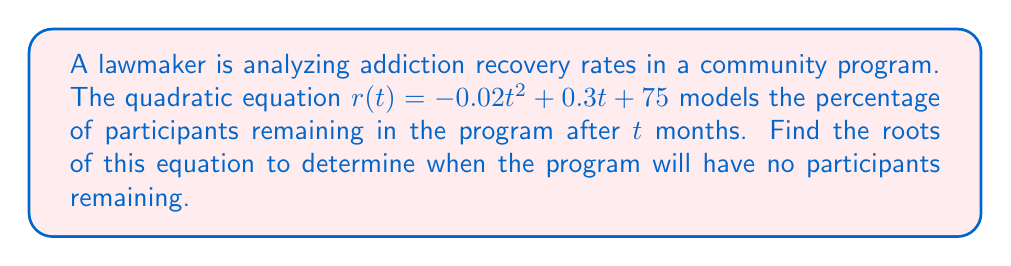Teach me how to tackle this problem. To find the roots of the quadratic equation, we need to solve $r(t) = 0$:

1) Set the equation equal to zero:
   $-0.02t^2 + 0.3t + 75 = 0$

2) Rearrange the equation to standard form $(at^2 + bt + c = 0)$:
   $0.02t^2 - 0.3t - 75 = 0$

3) Use the quadratic formula: $t = \frac{-b \pm \sqrt{b^2 - 4ac}}{2a}$
   Where $a = 0.02$, $b = -0.3$, and $c = -75$

4) Substitute these values into the quadratic formula:
   $t = \frac{0.3 \pm \sqrt{(-0.3)^2 - 4(0.02)(-75)}}{2(0.02)}$

5) Simplify under the square root:
   $t = \frac{0.3 \pm \sqrt{0.09 + 6}}{0.04} = \frac{0.3 \pm \sqrt{6.09}}{0.04}$

6) Calculate the square root:
   $t = \frac{0.3 \pm 2.468}{0.04}$

7) Solve for both roots:
   $t_1 = \frac{0.3 + 2.468}{0.04} \approx 69.2$
   $t_2 = \frac{0.3 - 2.468}{0.04} \approx -54.2$

8) Since time cannot be negative, we discard the negative root.

Therefore, the program will have no participants remaining after approximately 69.2 months.
Answer: $t \approx 69.2$ months 